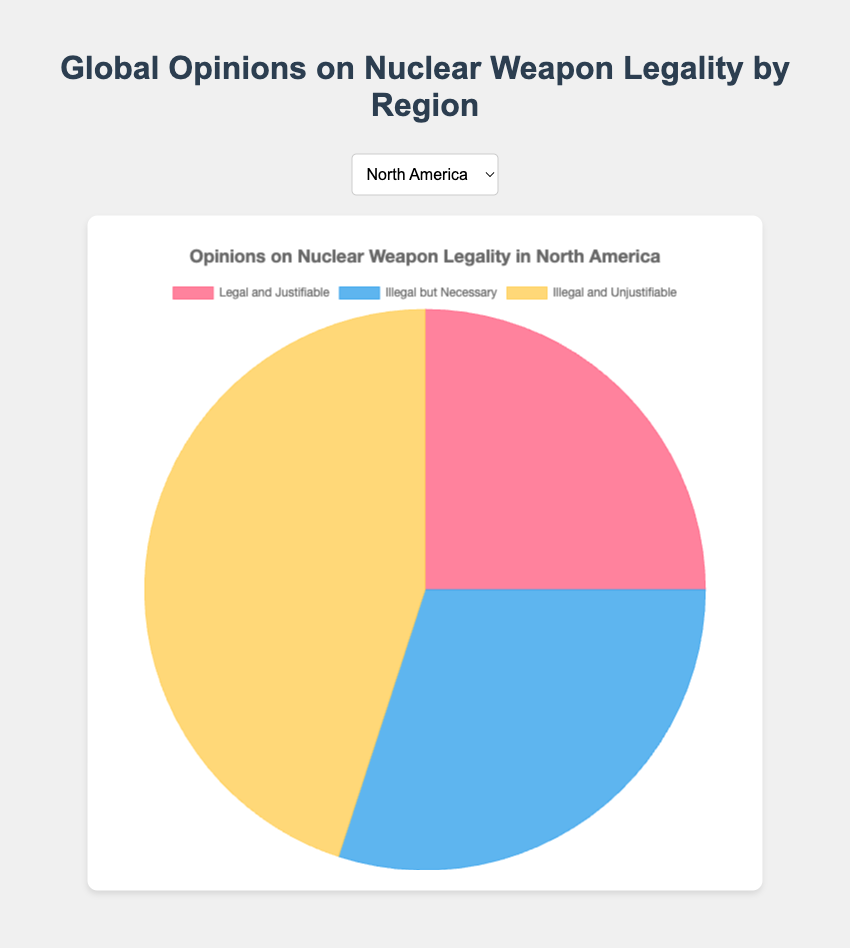What region has the highest percentage of opinions that believe nuclear weapons are "Illegal and Unjustifiable"? The chart shows each region's breakdown of opinions on nuclear weapon legality. Africa has the largest slice of the pie chart for "Illegal and Unjustifiable" in dark yellow.
Answer: Africa Compare the percentage of people who believe nuclear weapons are "Legal and Justifiable" in North America and Africa. Which region has a higher percentage? North America has a larger portion in the lighter yellow section of the pie chart compared to Africa. North America shows 25% for "Legal and Justifiable", whereas Africa shows only 5%.
Answer: North America What is the difference in the number of people who believe nuclear weapons are "Illegal but Necessary" between Europe and South America? The pie charts for Europe and South America show percentages for "Illegal but Necessary" in blue. Europe has 35%, while South America has 25%. The difference is 35% - 25% = 10%.
Answer: 10% Which region has an equal percentage of opinions for "Illegal and Unjustifiable" and another region? Observing the pie chart slices for "Illegal and Unjustifiable" in yellow, both North America and Europe have 45%.
Answer: North America and Europe What is the combined percentage of people in Oceania who believe nuclear weapons are either "Illegal but Necessary" or "Illegal and Unjustifiable"? By adding the percentages for "Illegal but Necessary" (32%) and "Illegal and Unjustifiable" (50%) from the Oceania pie chart, we get 32% + 50% = 82%.
Answer: 82% Which region shows the most balanced opinion distribution between the three categories? The pie chart for North America shows that the slices are more balanced with 25% for "Legal and Justifiable", 30% for "Illegal but Necessary", and 45% for "Illegal and Unjustifiable".
Answer: North America In which region is the opinion that nuclear weapons are "Illegal but Necessary" most prevalent? By analyzing the blue sections of the pie charts, Asia has the highest percentage with 40%.
Answer: Asia 